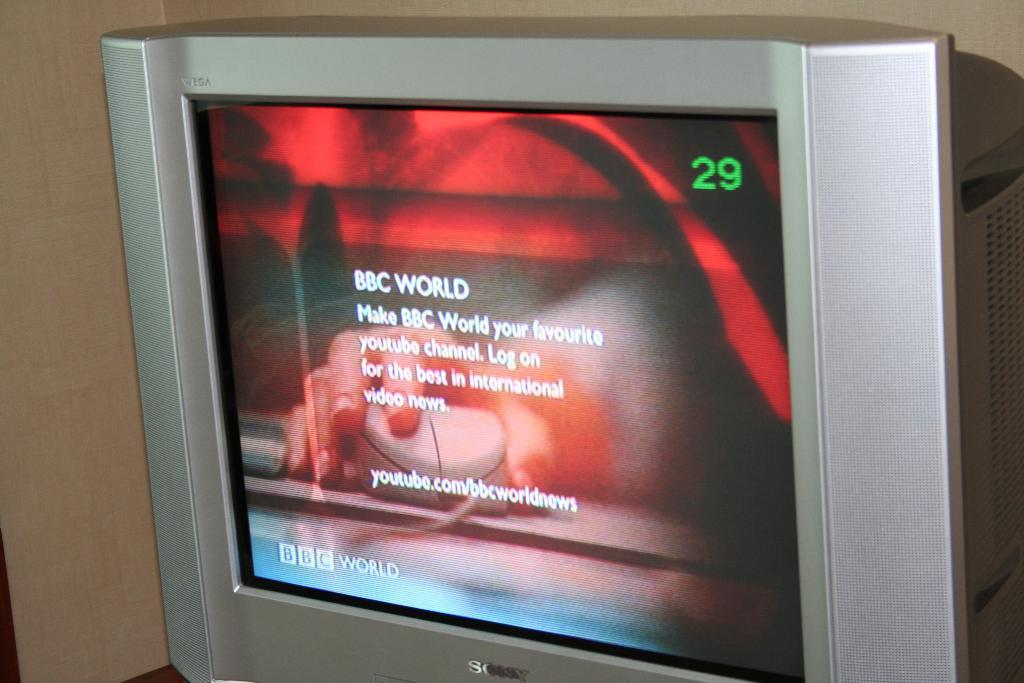<image>
Give a short and clear explanation of the subsequent image. a monitor on channel 29 shows a news snippit by BBC WORLD 